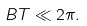Convert formula to latex. <formula><loc_0><loc_0><loc_500><loc_500>B T \ll 2 \pi .</formula> 